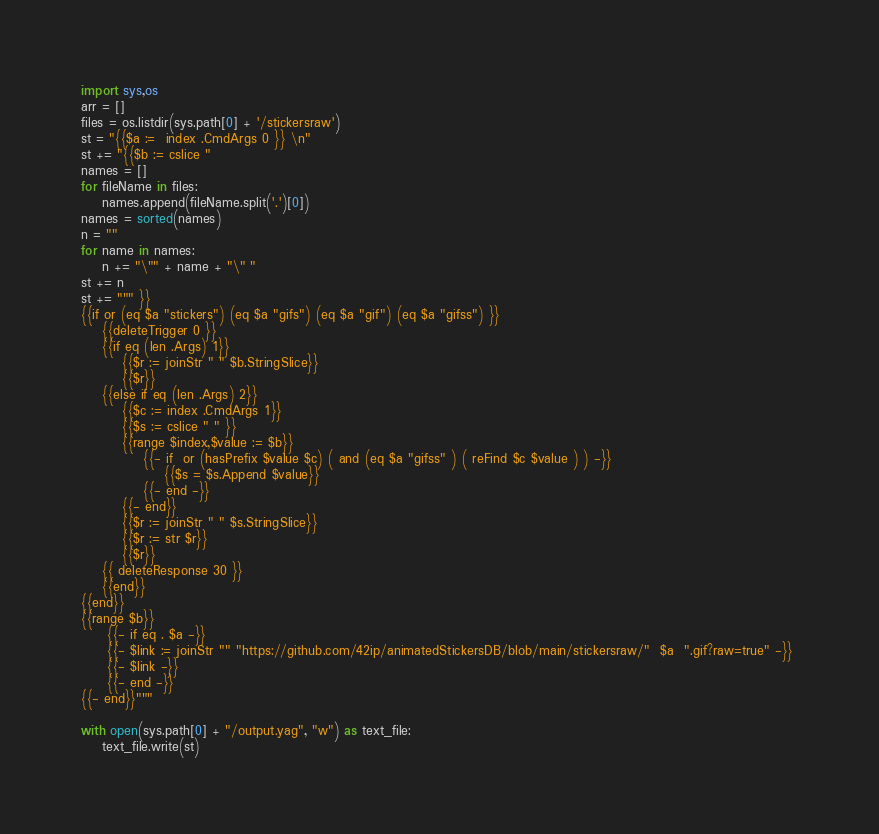<code> <loc_0><loc_0><loc_500><loc_500><_Python_>import sys,os
arr = []
files = os.listdir(sys.path[0] + '/stickersraw')
st = "{{$a :=  index .CmdArgs 0 }} \n"
st += "{{$b := cslice "
names = []
for fileName in files:
    names.append(fileName.split('.')[0])
names = sorted(names)
n = ""
for name in names:    
    n += "\"" + name + "\" "
st += n
st += """ }}
{{if or (eq $a "stickers") (eq $a "gifs") (eq $a "gif") (eq $a "gifss") }} 
	{{deleteTrigger 0 }}
	{{if eq (len .Args) 1}}
		{{$r := joinStr " " $b.StringSlice}}
		{{$r}}
	{{else if eq (len .Args) 2}}
	 	{{$c := index .CmdArgs 1}}
		{{$s := cslice " " }}
		{{range $index,$value := $b}}
			{{- if  or (hasPrefix $value $c) ( and (eq $a "gifss" ) ( reFind $c $value ) ) -}}
				{{$s = $s.Append $value}}
			{{- end -}}
		{{- end}}
		{{$r := joinStr " " $s.StringSlice}}
		{{$r := str $r}}
		{{$r}}
	{{ deleteResponse 30 }}
	{{end}}
{{end}}
{{range $b}} 
	 {{- if eq . $a -}}
	 {{- $link := joinStr "" "https://github.com/42ip/animatedStickersDB/blob/main/stickersraw/"  $a  ".gif?raw=true" -}} 
	 {{- $link -}} 
	 {{- end -}} 
{{- end}}"""

with open(sys.path[0] + "/output.yag", "w") as text_file:
    text_file.write(st)</code> 